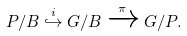<formula> <loc_0><loc_0><loc_500><loc_500>P / B \overset { i } { \hookrightarrow } G / B \xrightarrow { \pi } G / P .</formula> 